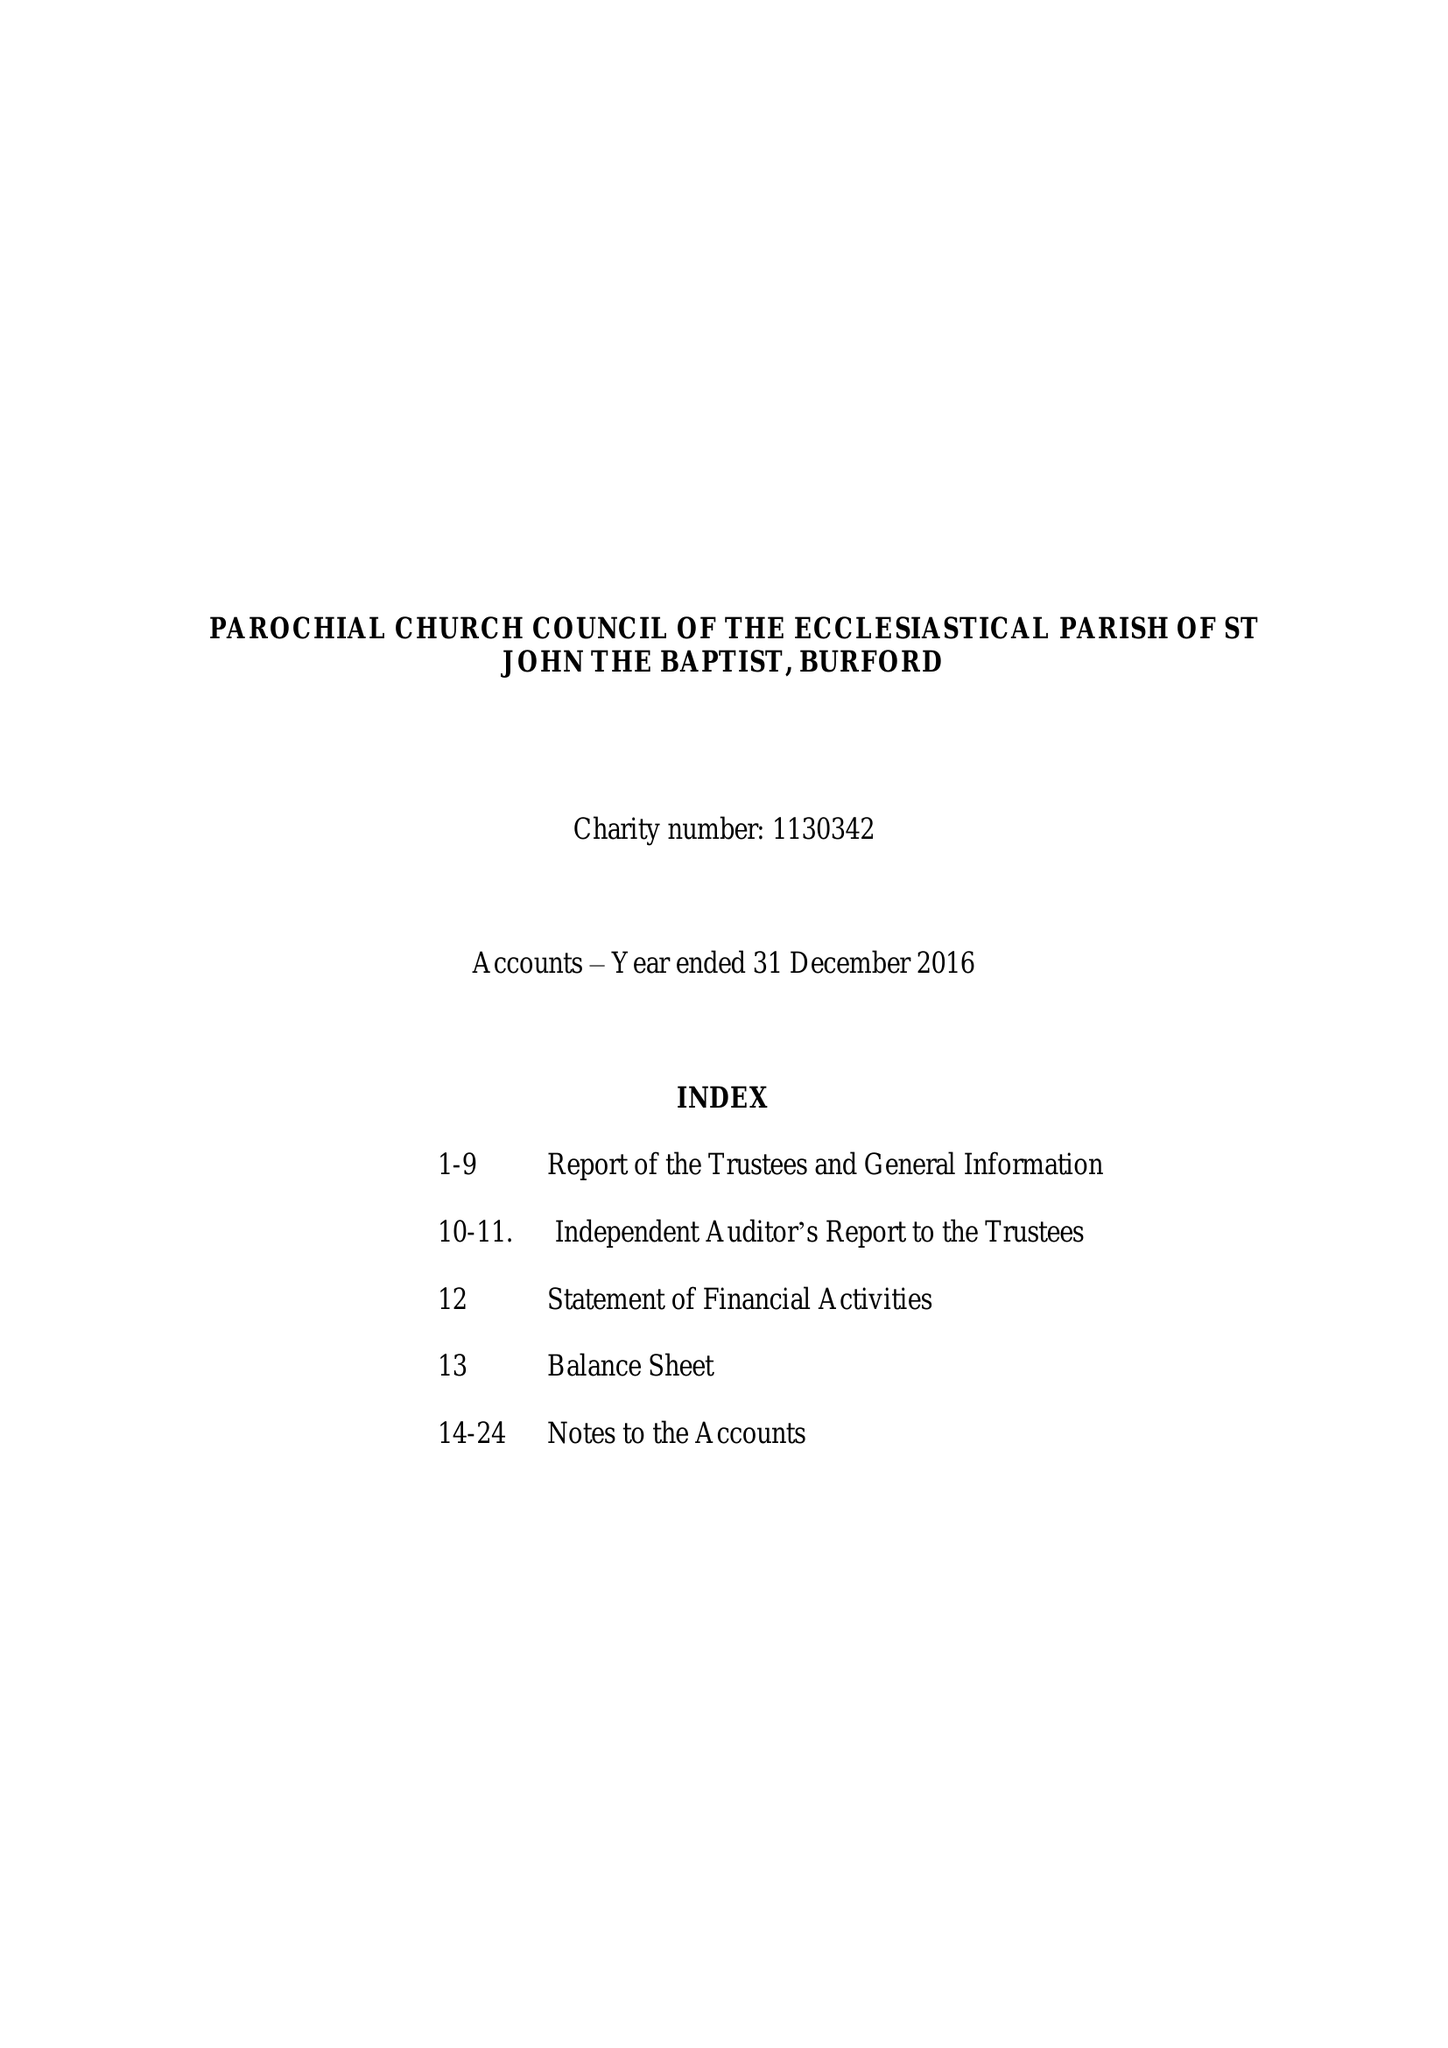What is the value for the charity_number?
Answer the question using a single word or phrase. 1130342 